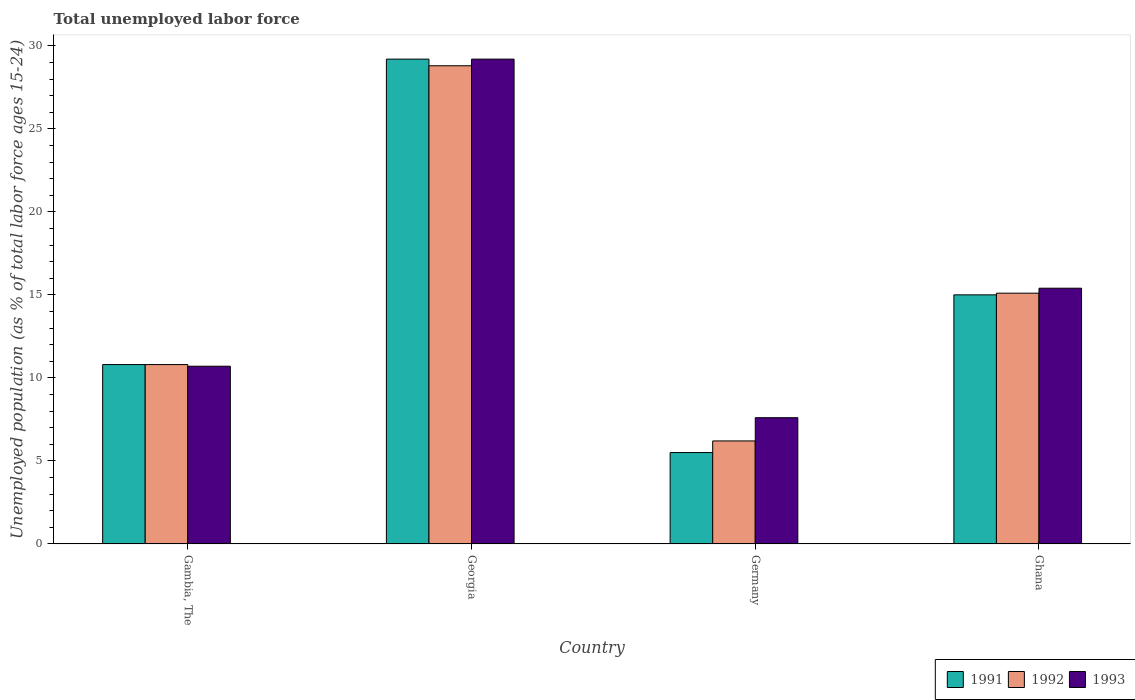Are the number of bars per tick equal to the number of legend labels?
Your response must be concise. Yes. Are the number of bars on each tick of the X-axis equal?
Offer a terse response. Yes. How many bars are there on the 3rd tick from the right?
Provide a short and direct response. 3. What is the label of the 1st group of bars from the left?
Provide a succinct answer. Gambia, The. What is the percentage of unemployed population in in 1993 in Georgia?
Your answer should be compact. 29.2. Across all countries, what is the maximum percentage of unemployed population in in 1992?
Your response must be concise. 28.8. Across all countries, what is the minimum percentage of unemployed population in in 1992?
Your answer should be compact. 6.2. In which country was the percentage of unemployed population in in 1992 maximum?
Provide a short and direct response. Georgia. In which country was the percentage of unemployed population in in 1993 minimum?
Your response must be concise. Germany. What is the total percentage of unemployed population in in 1992 in the graph?
Give a very brief answer. 60.9. What is the difference between the percentage of unemployed population in in 1992 in Gambia, The and that in Georgia?
Ensure brevity in your answer.  -18. What is the difference between the percentage of unemployed population in in 1993 in Georgia and the percentage of unemployed population in in 1991 in Gambia, The?
Make the answer very short. 18.4. What is the average percentage of unemployed population in in 1993 per country?
Keep it short and to the point. 15.73. What is the difference between the percentage of unemployed population in of/in 1993 and percentage of unemployed population in of/in 1992 in Georgia?
Provide a succinct answer. 0.4. What is the ratio of the percentage of unemployed population in in 1993 in Gambia, The to that in Germany?
Keep it short and to the point. 1.41. Is the percentage of unemployed population in in 1991 in Gambia, The less than that in Germany?
Your answer should be very brief. No. What is the difference between the highest and the second highest percentage of unemployed population in in 1992?
Offer a terse response. -18. What is the difference between the highest and the lowest percentage of unemployed population in in 1992?
Provide a short and direct response. 22.6. In how many countries, is the percentage of unemployed population in in 1991 greater than the average percentage of unemployed population in in 1991 taken over all countries?
Keep it short and to the point. 1. What does the 3rd bar from the right in Gambia, The represents?
Provide a short and direct response. 1991. How many bars are there?
Your response must be concise. 12. Are all the bars in the graph horizontal?
Your response must be concise. No. How many countries are there in the graph?
Provide a short and direct response. 4. Does the graph contain grids?
Provide a short and direct response. No. Where does the legend appear in the graph?
Offer a very short reply. Bottom right. What is the title of the graph?
Your answer should be very brief. Total unemployed labor force. What is the label or title of the Y-axis?
Keep it short and to the point. Unemployed population (as % of total labor force ages 15-24). What is the Unemployed population (as % of total labor force ages 15-24) in 1991 in Gambia, The?
Keep it short and to the point. 10.8. What is the Unemployed population (as % of total labor force ages 15-24) of 1992 in Gambia, The?
Make the answer very short. 10.8. What is the Unemployed population (as % of total labor force ages 15-24) in 1993 in Gambia, The?
Provide a short and direct response. 10.7. What is the Unemployed population (as % of total labor force ages 15-24) of 1991 in Georgia?
Your answer should be very brief. 29.2. What is the Unemployed population (as % of total labor force ages 15-24) of 1992 in Georgia?
Offer a very short reply. 28.8. What is the Unemployed population (as % of total labor force ages 15-24) in 1993 in Georgia?
Your response must be concise. 29.2. What is the Unemployed population (as % of total labor force ages 15-24) in 1991 in Germany?
Give a very brief answer. 5.5. What is the Unemployed population (as % of total labor force ages 15-24) of 1992 in Germany?
Your answer should be compact. 6.2. What is the Unemployed population (as % of total labor force ages 15-24) in 1993 in Germany?
Your response must be concise. 7.6. What is the Unemployed population (as % of total labor force ages 15-24) of 1992 in Ghana?
Give a very brief answer. 15.1. What is the Unemployed population (as % of total labor force ages 15-24) of 1993 in Ghana?
Keep it short and to the point. 15.4. Across all countries, what is the maximum Unemployed population (as % of total labor force ages 15-24) of 1991?
Your response must be concise. 29.2. Across all countries, what is the maximum Unemployed population (as % of total labor force ages 15-24) in 1992?
Your answer should be very brief. 28.8. Across all countries, what is the maximum Unemployed population (as % of total labor force ages 15-24) of 1993?
Offer a terse response. 29.2. Across all countries, what is the minimum Unemployed population (as % of total labor force ages 15-24) of 1991?
Provide a succinct answer. 5.5. Across all countries, what is the minimum Unemployed population (as % of total labor force ages 15-24) in 1992?
Provide a short and direct response. 6.2. Across all countries, what is the minimum Unemployed population (as % of total labor force ages 15-24) in 1993?
Offer a very short reply. 7.6. What is the total Unemployed population (as % of total labor force ages 15-24) of 1991 in the graph?
Give a very brief answer. 60.5. What is the total Unemployed population (as % of total labor force ages 15-24) in 1992 in the graph?
Provide a short and direct response. 60.9. What is the total Unemployed population (as % of total labor force ages 15-24) of 1993 in the graph?
Your answer should be compact. 62.9. What is the difference between the Unemployed population (as % of total labor force ages 15-24) of 1991 in Gambia, The and that in Georgia?
Provide a succinct answer. -18.4. What is the difference between the Unemployed population (as % of total labor force ages 15-24) of 1993 in Gambia, The and that in Georgia?
Make the answer very short. -18.5. What is the difference between the Unemployed population (as % of total labor force ages 15-24) in 1991 in Gambia, The and that in Germany?
Offer a very short reply. 5.3. What is the difference between the Unemployed population (as % of total labor force ages 15-24) in 1993 in Gambia, The and that in Germany?
Keep it short and to the point. 3.1. What is the difference between the Unemployed population (as % of total labor force ages 15-24) of 1991 in Gambia, The and that in Ghana?
Your answer should be compact. -4.2. What is the difference between the Unemployed population (as % of total labor force ages 15-24) in 1993 in Gambia, The and that in Ghana?
Provide a succinct answer. -4.7. What is the difference between the Unemployed population (as % of total labor force ages 15-24) of 1991 in Georgia and that in Germany?
Make the answer very short. 23.7. What is the difference between the Unemployed population (as % of total labor force ages 15-24) in 1992 in Georgia and that in Germany?
Give a very brief answer. 22.6. What is the difference between the Unemployed population (as % of total labor force ages 15-24) in 1993 in Georgia and that in Germany?
Ensure brevity in your answer.  21.6. What is the difference between the Unemployed population (as % of total labor force ages 15-24) in 1992 in Georgia and that in Ghana?
Your answer should be compact. 13.7. What is the difference between the Unemployed population (as % of total labor force ages 15-24) of 1991 in Germany and that in Ghana?
Ensure brevity in your answer.  -9.5. What is the difference between the Unemployed population (as % of total labor force ages 15-24) of 1992 in Germany and that in Ghana?
Your answer should be compact. -8.9. What is the difference between the Unemployed population (as % of total labor force ages 15-24) of 1991 in Gambia, The and the Unemployed population (as % of total labor force ages 15-24) of 1993 in Georgia?
Give a very brief answer. -18.4. What is the difference between the Unemployed population (as % of total labor force ages 15-24) of 1992 in Gambia, The and the Unemployed population (as % of total labor force ages 15-24) of 1993 in Georgia?
Make the answer very short. -18.4. What is the difference between the Unemployed population (as % of total labor force ages 15-24) in 1991 in Gambia, The and the Unemployed population (as % of total labor force ages 15-24) in 1992 in Germany?
Your answer should be very brief. 4.6. What is the difference between the Unemployed population (as % of total labor force ages 15-24) of 1992 in Gambia, The and the Unemployed population (as % of total labor force ages 15-24) of 1993 in Germany?
Provide a succinct answer. 3.2. What is the difference between the Unemployed population (as % of total labor force ages 15-24) in 1991 in Gambia, The and the Unemployed population (as % of total labor force ages 15-24) in 1993 in Ghana?
Your response must be concise. -4.6. What is the difference between the Unemployed population (as % of total labor force ages 15-24) of 1991 in Georgia and the Unemployed population (as % of total labor force ages 15-24) of 1993 in Germany?
Offer a very short reply. 21.6. What is the difference between the Unemployed population (as % of total labor force ages 15-24) of 1992 in Georgia and the Unemployed population (as % of total labor force ages 15-24) of 1993 in Germany?
Make the answer very short. 21.2. What is the difference between the Unemployed population (as % of total labor force ages 15-24) of 1991 in Georgia and the Unemployed population (as % of total labor force ages 15-24) of 1992 in Ghana?
Provide a short and direct response. 14.1. What is the difference between the Unemployed population (as % of total labor force ages 15-24) in 1991 in Germany and the Unemployed population (as % of total labor force ages 15-24) in 1992 in Ghana?
Ensure brevity in your answer.  -9.6. What is the average Unemployed population (as % of total labor force ages 15-24) of 1991 per country?
Ensure brevity in your answer.  15.12. What is the average Unemployed population (as % of total labor force ages 15-24) in 1992 per country?
Your answer should be compact. 15.22. What is the average Unemployed population (as % of total labor force ages 15-24) of 1993 per country?
Provide a succinct answer. 15.72. What is the difference between the Unemployed population (as % of total labor force ages 15-24) of 1991 and Unemployed population (as % of total labor force ages 15-24) of 1992 in Gambia, The?
Your answer should be compact. 0. What is the difference between the Unemployed population (as % of total labor force ages 15-24) of 1992 and Unemployed population (as % of total labor force ages 15-24) of 1993 in Gambia, The?
Make the answer very short. 0.1. What is the difference between the Unemployed population (as % of total labor force ages 15-24) in 1991 and Unemployed population (as % of total labor force ages 15-24) in 1992 in Georgia?
Keep it short and to the point. 0.4. What is the difference between the Unemployed population (as % of total labor force ages 15-24) of 1992 and Unemployed population (as % of total labor force ages 15-24) of 1993 in Georgia?
Make the answer very short. -0.4. What is the difference between the Unemployed population (as % of total labor force ages 15-24) in 1991 and Unemployed population (as % of total labor force ages 15-24) in 1992 in Germany?
Ensure brevity in your answer.  -0.7. What is the difference between the Unemployed population (as % of total labor force ages 15-24) in 1991 and Unemployed population (as % of total labor force ages 15-24) in 1993 in Germany?
Give a very brief answer. -2.1. What is the difference between the Unemployed population (as % of total labor force ages 15-24) in 1991 and Unemployed population (as % of total labor force ages 15-24) in 1993 in Ghana?
Offer a terse response. -0.4. What is the ratio of the Unemployed population (as % of total labor force ages 15-24) of 1991 in Gambia, The to that in Georgia?
Offer a very short reply. 0.37. What is the ratio of the Unemployed population (as % of total labor force ages 15-24) in 1992 in Gambia, The to that in Georgia?
Ensure brevity in your answer.  0.38. What is the ratio of the Unemployed population (as % of total labor force ages 15-24) of 1993 in Gambia, The to that in Georgia?
Keep it short and to the point. 0.37. What is the ratio of the Unemployed population (as % of total labor force ages 15-24) of 1991 in Gambia, The to that in Germany?
Offer a very short reply. 1.96. What is the ratio of the Unemployed population (as % of total labor force ages 15-24) of 1992 in Gambia, The to that in Germany?
Provide a short and direct response. 1.74. What is the ratio of the Unemployed population (as % of total labor force ages 15-24) of 1993 in Gambia, The to that in Germany?
Ensure brevity in your answer.  1.41. What is the ratio of the Unemployed population (as % of total labor force ages 15-24) of 1991 in Gambia, The to that in Ghana?
Provide a succinct answer. 0.72. What is the ratio of the Unemployed population (as % of total labor force ages 15-24) of 1992 in Gambia, The to that in Ghana?
Give a very brief answer. 0.72. What is the ratio of the Unemployed population (as % of total labor force ages 15-24) in 1993 in Gambia, The to that in Ghana?
Give a very brief answer. 0.69. What is the ratio of the Unemployed population (as % of total labor force ages 15-24) in 1991 in Georgia to that in Germany?
Provide a short and direct response. 5.31. What is the ratio of the Unemployed population (as % of total labor force ages 15-24) in 1992 in Georgia to that in Germany?
Provide a short and direct response. 4.65. What is the ratio of the Unemployed population (as % of total labor force ages 15-24) in 1993 in Georgia to that in Germany?
Offer a very short reply. 3.84. What is the ratio of the Unemployed population (as % of total labor force ages 15-24) in 1991 in Georgia to that in Ghana?
Keep it short and to the point. 1.95. What is the ratio of the Unemployed population (as % of total labor force ages 15-24) in 1992 in Georgia to that in Ghana?
Give a very brief answer. 1.91. What is the ratio of the Unemployed population (as % of total labor force ages 15-24) in 1993 in Georgia to that in Ghana?
Make the answer very short. 1.9. What is the ratio of the Unemployed population (as % of total labor force ages 15-24) of 1991 in Germany to that in Ghana?
Your answer should be very brief. 0.37. What is the ratio of the Unemployed population (as % of total labor force ages 15-24) in 1992 in Germany to that in Ghana?
Provide a succinct answer. 0.41. What is the ratio of the Unemployed population (as % of total labor force ages 15-24) in 1993 in Germany to that in Ghana?
Keep it short and to the point. 0.49. What is the difference between the highest and the second highest Unemployed population (as % of total labor force ages 15-24) of 1992?
Offer a very short reply. 13.7. What is the difference between the highest and the lowest Unemployed population (as % of total labor force ages 15-24) of 1991?
Make the answer very short. 23.7. What is the difference between the highest and the lowest Unemployed population (as % of total labor force ages 15-24) in 1992?
Make the answer very short. 22.6. What is the difference between the highest and the lowest Unemployed population (as % of total labor force ages 15-24) of 1993?
Provide a short and direct response. 21.6. 